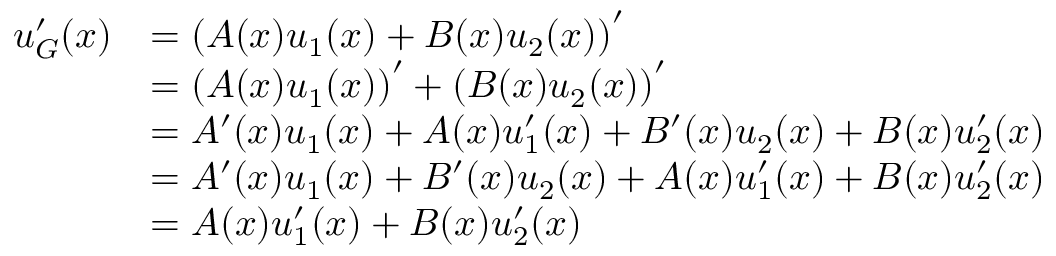Convert formula to latex. <formula><loc_0><loc_0><loc_500><loc_500>{ \begin{array} { r l } { u _ { G } ^ { \prime } ( x ) } & { = \left ( A ( x ) u _ { 1 } ( x ) + B ( x ) u _ { 2 } ( x ) \right ) ^ { \prime } } \\ & { = \left ( A ( x ) u _ { 1 } ( x ) \right ) ^ { \prime } + \left ( B ( x ) u _ { 2 } ( x ) \right ) ^ { \prime } } \\ & { = A ^ { \prime } ( x ) u _ { 1 } ( x ) + A ( x ) u _ { 1 } ^ { \prime } ( x ) + B ^ { \prime } ( x ) u _ { 2 } ( x ) + B ( x ) u _ { 2 } ^ { \prime } ( x ) } \\ & { = A ^ { \prime } ( x ) u _ { 1 } ( x ) + B ^ { \prime } ( x ) u _ { 2 } ( x ) + A ( x ) u _ { 1 } ^ { \prime } ( x ) + B ( x ) u _ { 2 } ^ { \prime } ( x ) } \\ & { = A ( x ) u _ { 1 } ^ { \prime } ( x ) + B ( x ) u _ { 2 } ^ { \prime } ( x ) } \end{array} }</formula> 